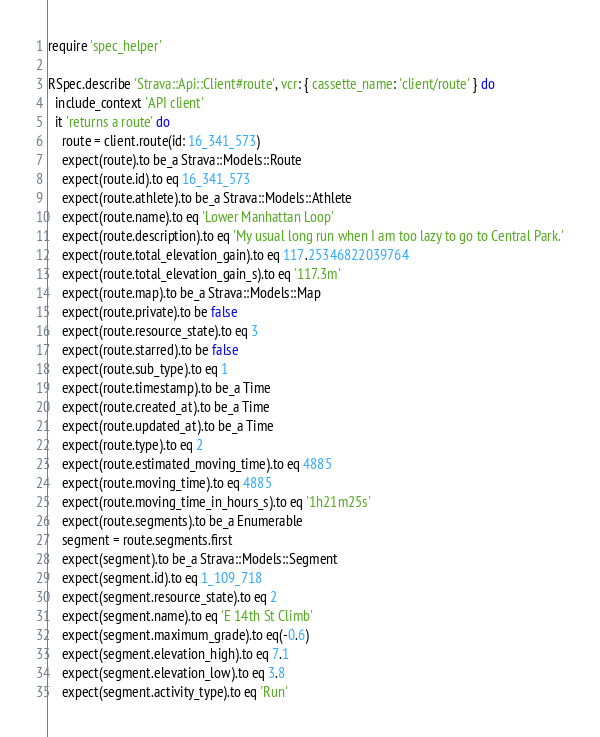<code> <loc_0><loc_0><loc_500><loc_500><_Ruby_>require 'spec_helper'

RSpec.describe 'Strava::Api::Client#route', vcr: { cassette_name: 'client/route' } do
  include_context 'API client'
  it 'returns a route' do
    route = client.route(id: 16_341_573)
    expect(route).to be_a Strava::Models::Route
    expect(route.id).to eq 16_341_573
    expect(route.athlete).to be_a Strava::Models::Athlete
    expect(route.name).to eq 'Lower Manhattan Loop'
    expect(route.description).to eq 'My usual long run when I am too lazy to go to Central Park.'
    expect(route.total_elevation_gain).to eq 117.25346822039764
    expect(route.total_elevation_gain_s).to eq '117.3m'
    expect(route.map).to be_a Strava::Models::Map
    expect(route.private).to be false
    expect(route.resource_state).to eq 3
    expect(route.starred).to be false
    expect(route.sub_type).to eq 1
    expect(route.timestamp).to be_a Time
    expect(route.created_at).to be_a Time
    expect(route.updated_at).to be_a Time
    expect(route.type).to eq 2
    expect(route.estimated_moving_time).to eq 4885
    expect(route.moving_time).to eq 4885
    expect(route.moving_time_in_hours_s).to eq '1h21m25s'
    expect(route.segments).to be_a Enumerable
    segment = route.segments.first
    expect(segment).to be_a Strava::Models::Segment
    expect(segment.id).to eq 1_109_718
    expect(segment.resource_state).to eq 2
    expect(segment.name).to eq 'E 14th St Climb'
    expect(segment.maximum_grade).to eq(-0.6)
    expect(segment.elevation_high).to eq 7.1
    expect(segment.elevation_low).to eq 3.8
    expect(segment.activity_type).to eq 'Run'</code> 